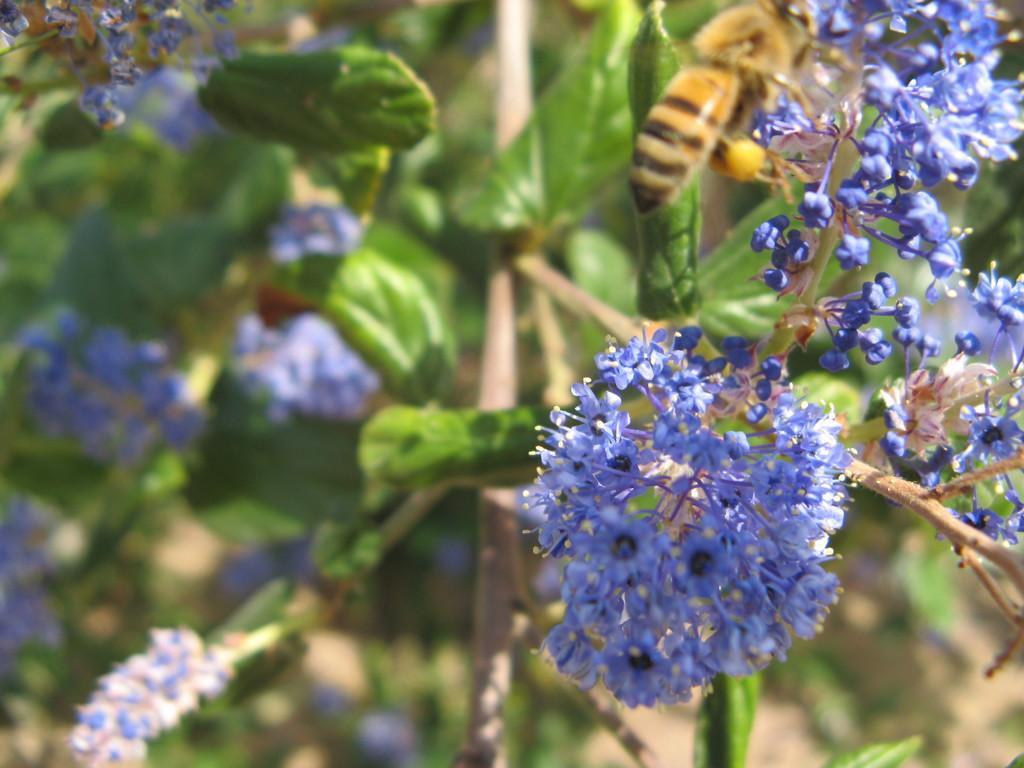Could you give a brief overview of what you see in this image? In this image I can see the blue color flowers to the plants. I can see an insect which is in brown and black color. 